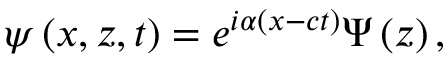Convert formula to latex. <formula><loc_0><loc_0><loc_500><loc_500>\psi \left ( x , z , t \right ) = e ^ { i \alpha \left ( x - c t \right ) } \Psi \left ( z \right ) ,</formula> 